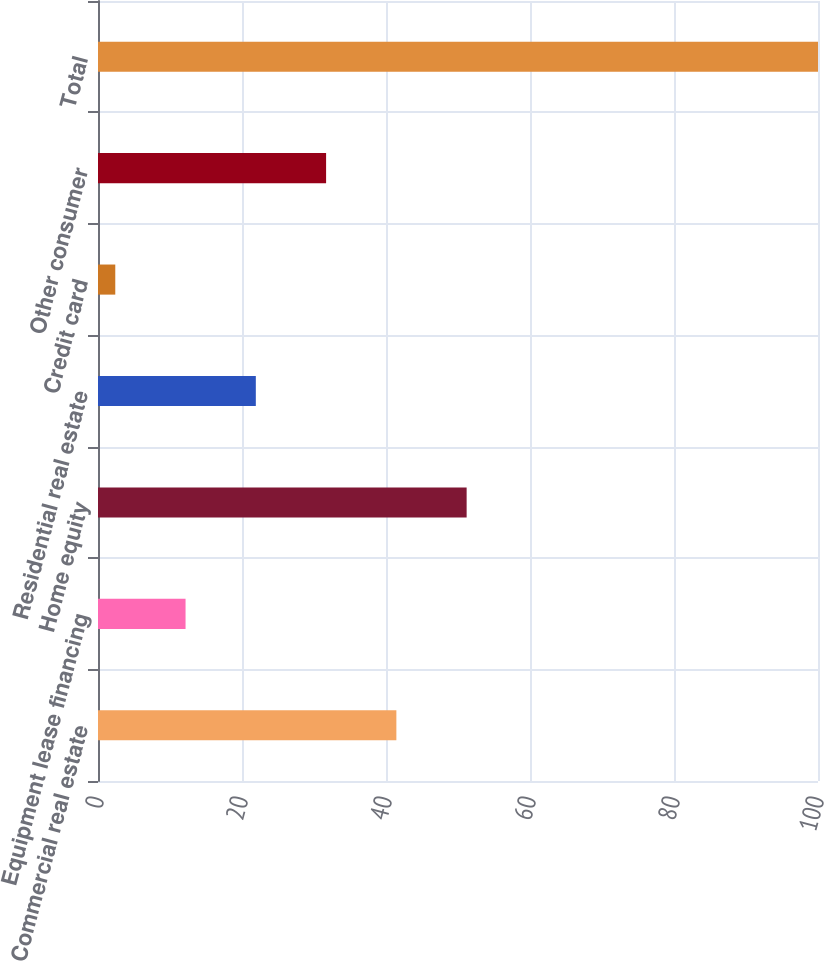Convert chart to OTSL. <chart><loc_0><loc_0><loc_500><loc_500><bar_chart><fcel>Commercial real estate<fcel>Equipment lease financing<fcel>Home equity<fcel>Residential real estate<fcel>Credit card<fcel>Other consumer<fcel>Total<nl><fcel>41.44<fcel>12.16<fcel>51.2<fcel>21.92<fcel>2.4<fcel>31.68<fcel>100<nl></chart> 